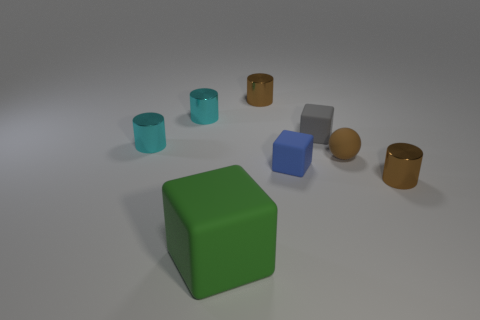Are all the objects in the image solids, or are there any hollow objects? From the image, it appears that the blue and light turquoise objects are cylindrical and likely hollow as suggested by their open tops, resembling cups or containers. The rest of the objects, which include cubes and spheres, look solid. 